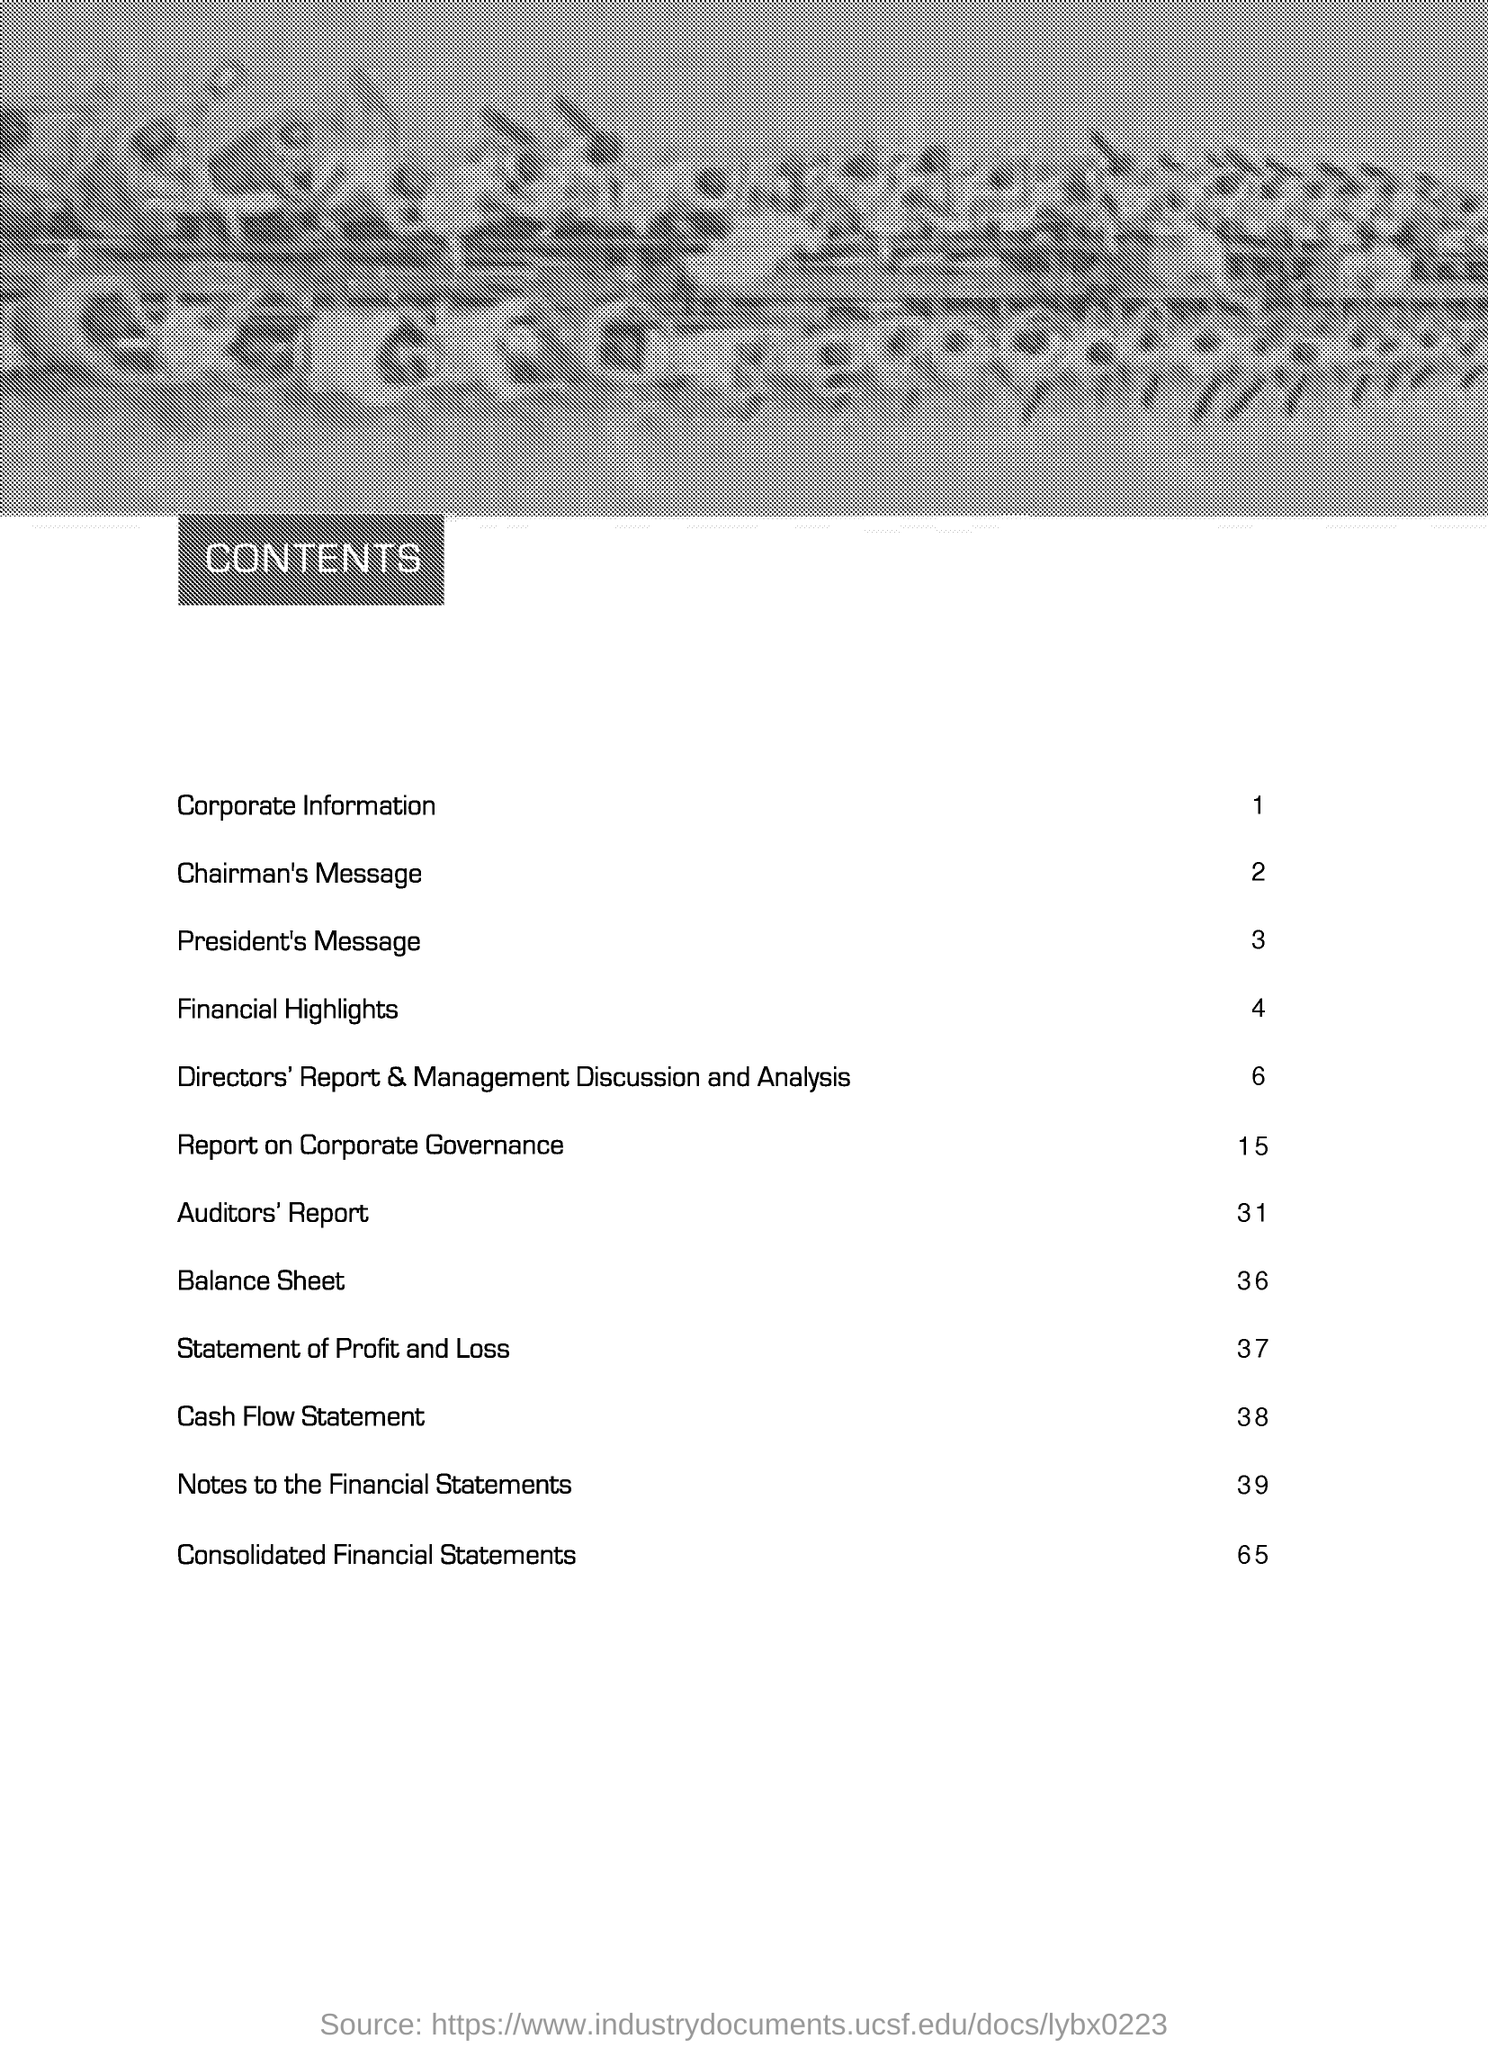Highlight a few significant elements in this photo. The page number of the "Consolidated Financial Statements" as per the content page is 65. The page number for the section "Corporate Information" as per the content page is 1. The page number of the "Chairman's Message" as per the content page is 2. The page number of "Cash Flow Statement" in the content is 38. 